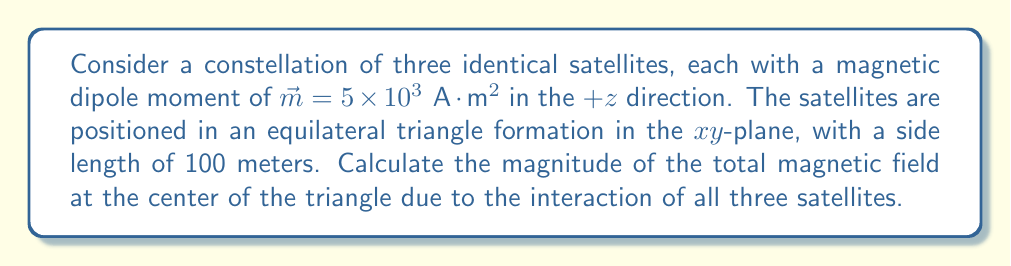Help me with this question. 1. First, let's determine the position vectors of the satellites relative to the center of the triangle. We can place the center at the origin (0,0,0) and position the satellites as follows:

   Satellite 1: $\vec{r}_1 = (0, 57.74, 0)$ m
   Satellite 2: $\vec{r}_2 = (-50, -28.87, 0)$ m
   Satellite 3: $\vec{r}_3 = (50, -28.87, 0)$ m

2. The magnetic field due to a magnetic dipole at a point $\vec{r}$ is given by:

   $$\vec{B} = \frac{\mu_0}{4\pi r^3} [3(\vec{m} \cdot \hat{r})\hat{r} - \vec{m}]$$

   Where $\mu_0 = 4\pi \times 10^{-7} \text{ T}\cdot\text{m}/\text{A}$ is the permeability of free space.

3. For each satellite, we need to calculate:
   
   $r = |\vec{r}| = 57.74 \text{ m}$ (same for all satellites due to symmetry)
   $\hat{r} = \vec{r} / r$
   $\vec{m} \cdot \hat{r} = 0$ (since $\vec{m}$ is perpendicular to $\vec{r}$ for all satellites)

4. Substituting these values into the equation:

   $$\vec{B}_i = \frac{\mu_0}{4\pi (57.74)^3} [0 - (0, 0, 5 \times 10^3)]$$
   $$\vec{B}_i = -2.60 \times 10^{-7} (0, 0, 1) \text{ T}$$

5. Due to the symmetry of the configuration, the x and y components of the magnetic fields from each satellite will cancel out at the center. The z components will add up.

6. The total magnetic field at the center is:

   $$\vec{B}_{total} = 3 \times (-2.60 \times 10^{-7}) (0, 0, 1) = -7.80 \times 10^{-7} (0, 0, 1) \text{ T}$$

7. The magnitude of this field is:

   $$|\vec{B}_{total}| = 7.80 \times 10^{-7} \text{ T}$$
Answer: $7.80 \times 10^{-7} \text{ T}$ 